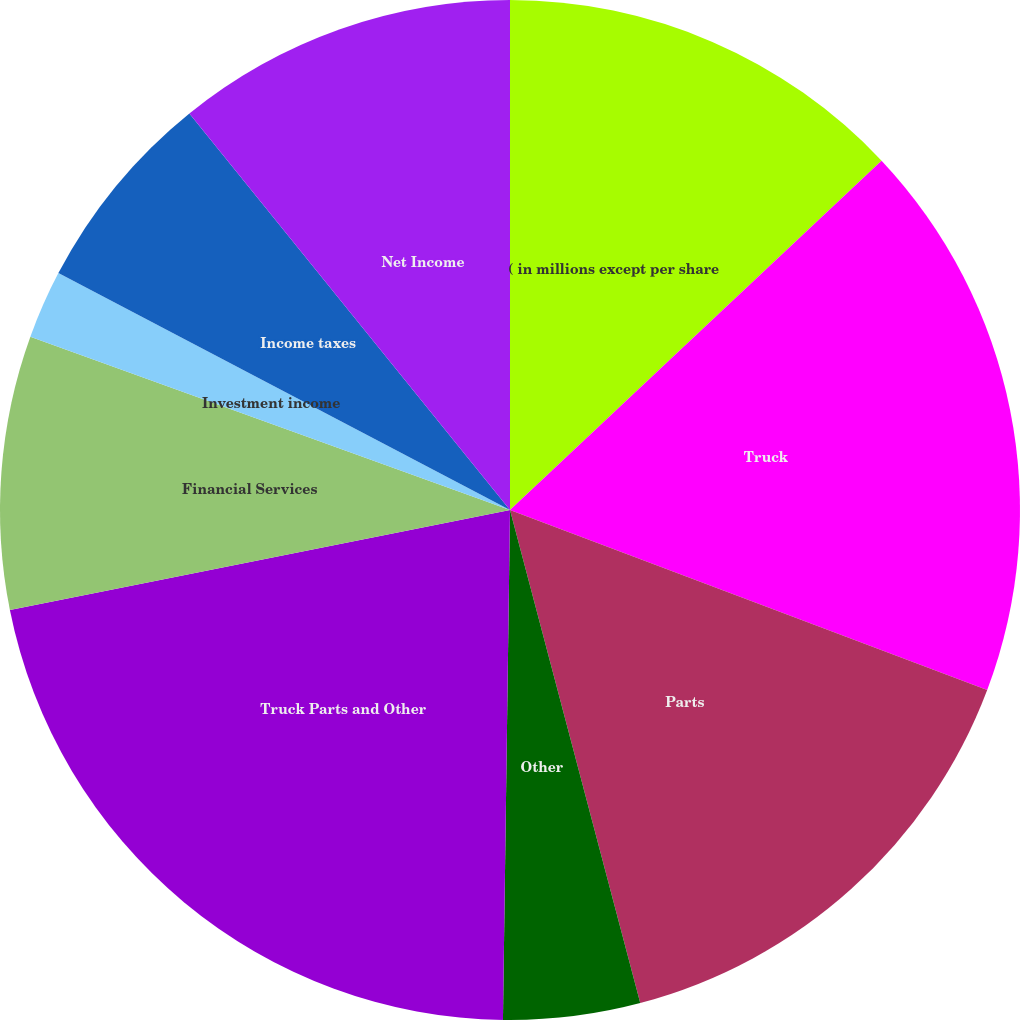<chart> <loc_0><loc_0><loc_500><loc_500><pie_chart><fcel>( in millions except per share<fcel>Truck<fcel>Parts<fcel>Other<fcel>Truck Parts and Other<fcel>Financial Services<fcel>Investment income<fcel>Income taxes<fcel>Net Income<fcel>Diluted earnings per share<nl><fcel>12.99%<fcel>17.75%<fcel>15.15%<fcel>4.33%<fcel>21.64%<fcel>8.66%<fcel>2.17%<fcel>6.49%<fcel>10.82%<fcel>0.0%<nl></chart> 